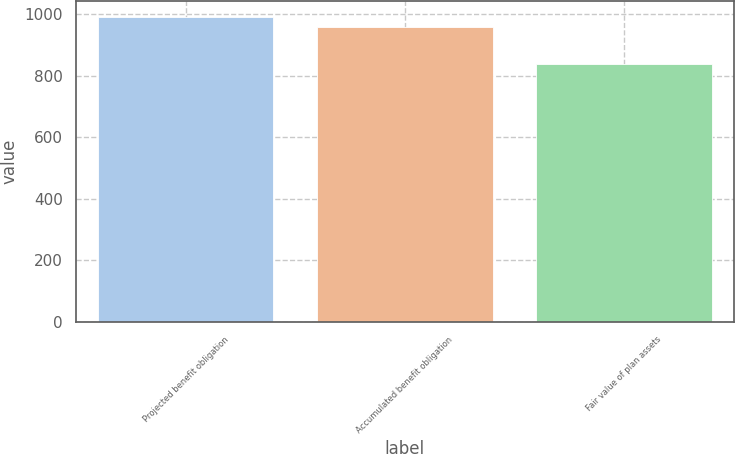Convert chart. <chart><loc_0><loc_0><loc_500><loc_500><bar_chart><fcel>Projected benefit obligation<fcel>Accumulated benefit obligation<fcel>Fair value of plan assets<nl><fcel>993<fcel>960<fcel>837<nl></chart> 